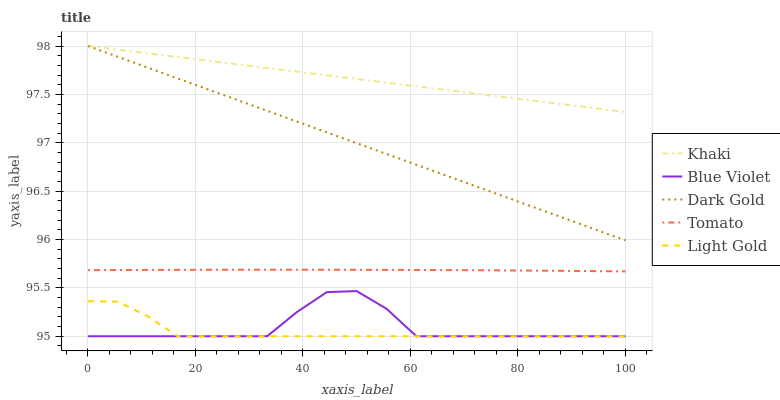Does Light Gold have the minimum area under the curve?
Answer yes or no. Yes. Does Khaki have the maximum area under the curve?
Answer yes or no. Yes. Does Khaki have the minimum area under the curve?
Answer yes or no. No. Does Light Gold have the maximum area under the curve?
Answer yes or no. No. Is Dark Gold the smoothest?
Answer yes or no. Yes. Is Blue Violet the roughest?
Answer yes or no. Yes. Is Khaki the smoothest?
Answer yes or no. No. Is Khaki the roughest?
Answer yes or no. No. Does Khaki have the lowest value?
Answer yes or no. No. Does Dark Gold have the highest value?
Answer yes or no. Yes. Does Light Gold have the highest value?
Answer yes or no. No. Is Blue Violet less than Tomato?
Answer yes or no. Yes. Is Tomato greater than Blue Violet?
Answer yes or no. Yes. Does Dark Gold intersect Khaki?
Answer yes or no. Yes. Is Dark Gold less than Khaki?
Answer yes or no. No. Is Dark Gold greater than Khaki?
Answer yes or no. No. Does Blue Violet intersect Tomato?
Answer yes or no. No. 